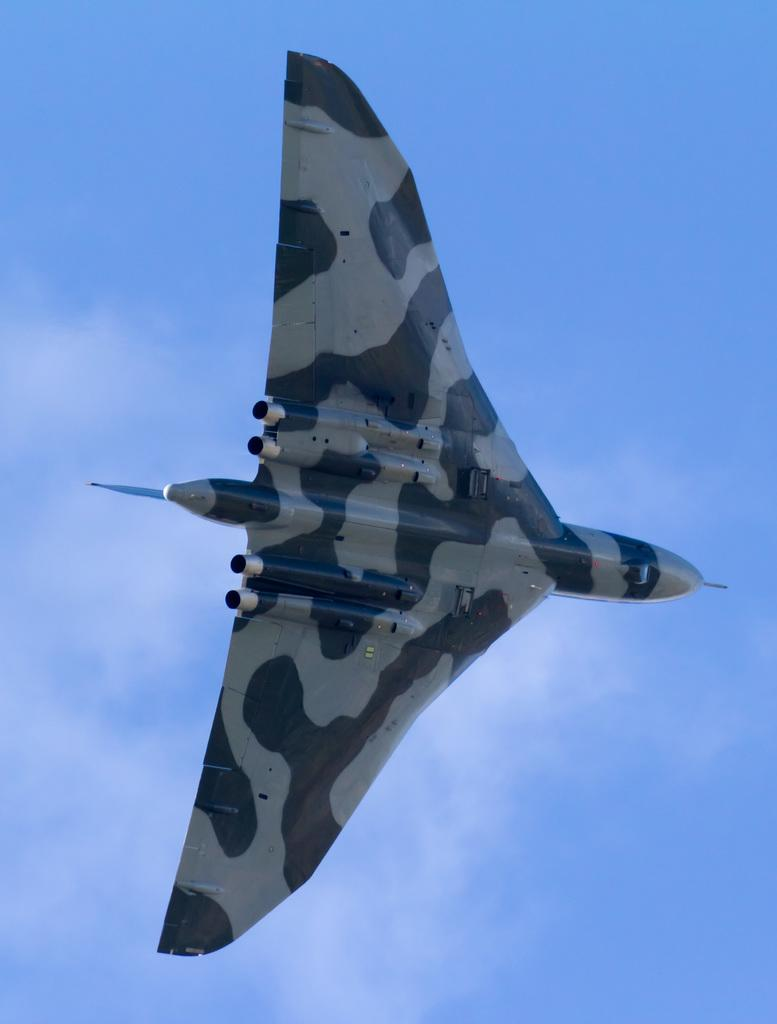What is the main subject of the picture? The main subject of the picture is an airplane. What is the color scheme of the airplane? The airplane is in black and white color. What is the airplane doing in the image? The airplane is flying in the air. What can be seen in the background of the image? There is a sky visible in the background of the image. What is the condition of the sky in the picture? Clouds are present in the sky. How many buttons can be seen on the airplane in the image? There are no buttons visible on the airplane in the image, as it is a black and white picture of an airplane flying in the sky. What type of industry is depicted in the image? The image does not depict any specific industry; it is a picture of an airplane flying in the sky. 